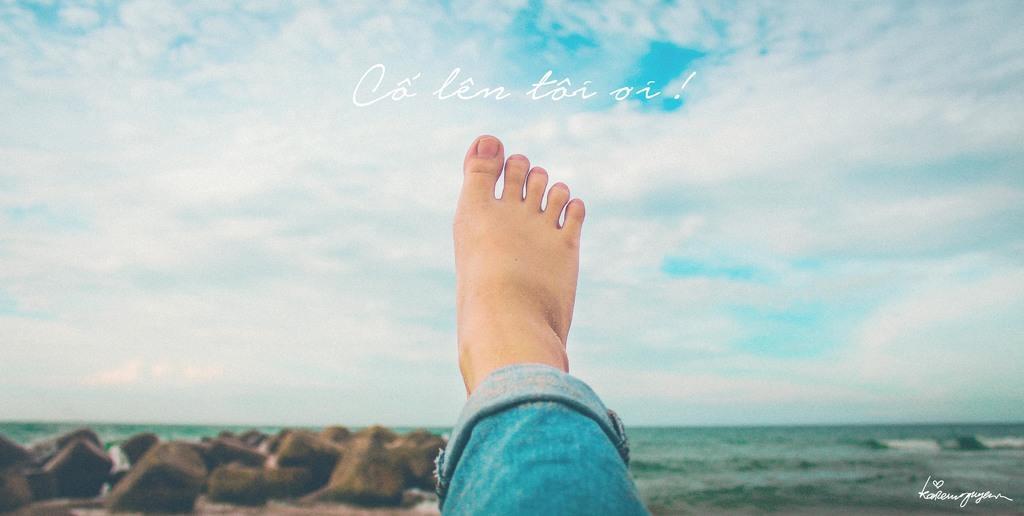How would you summarize this image in a sentence or two? In this image I can see a person's leg who is wearing a jeans. I can see few rocks and the water. In the background I can see the sky. 